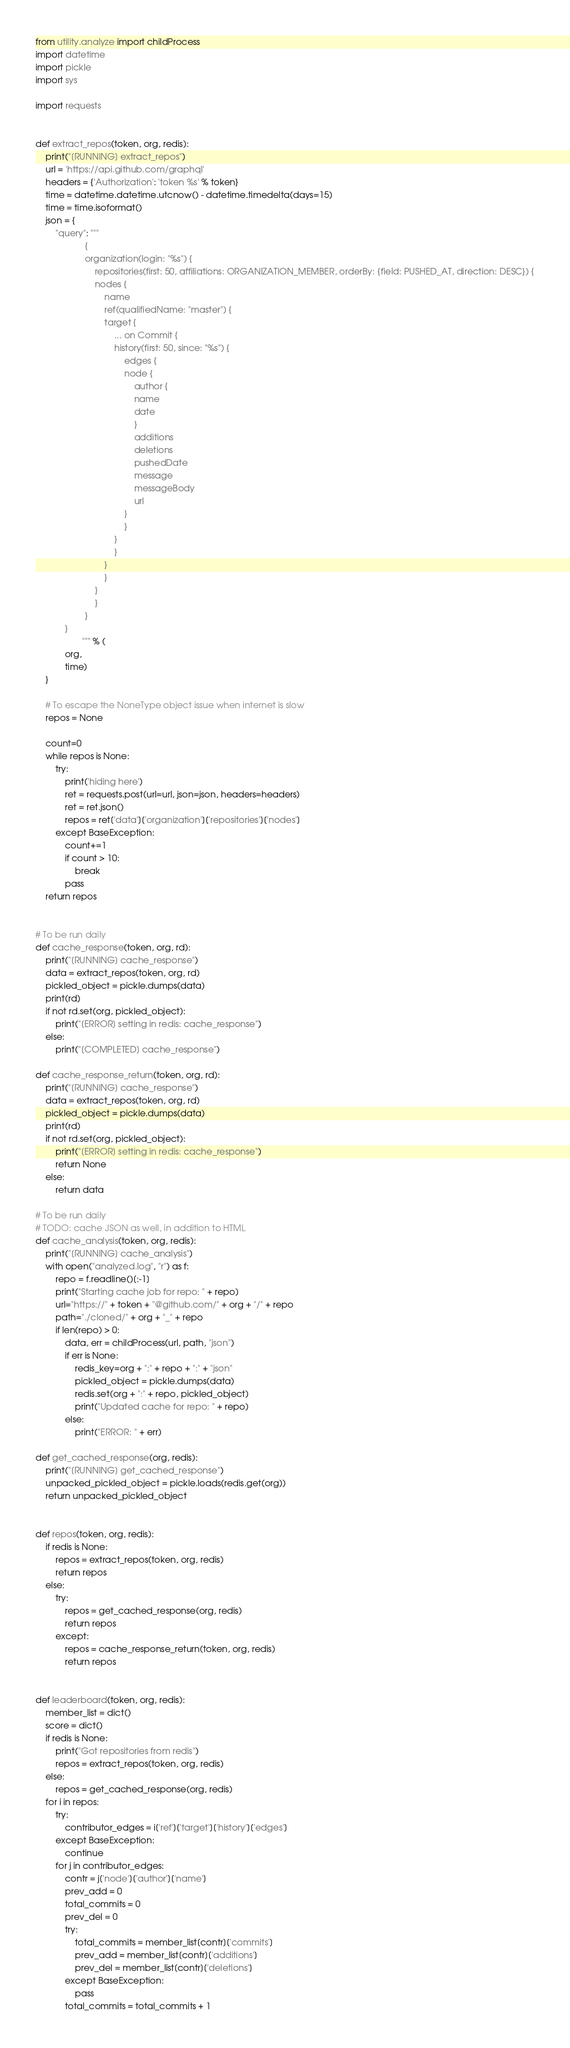<code> <loc_0><loc_0><loc_500><loc_500><_Python_>from utility.analyze import childProcess
import datetime
import pickle
import sys

import requests


def extract_repos(token, org, redis):
    print("[RUNNING] extract_repos")
    url = 'https://api.github.com/graphql'
    headers = {'Authorization': 'token %s' % token}
    time = datetime.datetime.utcnow() - datetime.timedelta(days=15)
    time = time.isoformat()
    json = {
        "query": """
                    {
                    organization(login: "%s") {
                        repositories(first: 50, affiliations: ORGANIZATION_MEMBER, orderBy: {field: PUSHED_AT, direction: DESC}) {
                        nodes {
                            name
                            ref(qualifiedName: "master") {
                            target {
                                ... on Commit {
                                history(first: 50, since: "%s") {
                                    edges {
                                    node {
                                        author {
                                        name
                                        date
                                        }
                                        additions
                                        deletions
                                        pushedDate
                                        message
                                        messageBody
                                        url
                                    }
                                    }
                                }
                                }
                            }
                            }
                        }
                        }
                    }
            }
                   """ % (
            org,
            time)
    }

    # To escape the NoneType object issue when internet is slow
    repos = None

    count=0
    while repos is None:
        try:
            print('hiding here')
            ret = requests.post(url=url, json=json, headers=headers)
            ret = ret.json()
            repos = ret['data']['organization']['repositories']['nodes']
        except BaseException:
            count+=1
            if count > 10:
                break
            pass
    return repos


# To be run daily
def cache_response(token, org, rd):
    print("[RUNNING] cache_response")
    data = extract_repos(token, org, rd)
    pickled_object = pickle.dumps(data)
    print(rd)
    if not rd.set(org, pickled_object):
        print("[ERROR] setting in redis: cache_response")
    else:
        print("[COMPLETED] cache_response")

def cache_response_return(token, org, rd):
    print("[RUNNING] cache_response")
    data = extract_repos(token, org, rd)
    pickled_object = pickle.dumps(data)
    print(rd)
    if not rd.set(org, pickled_object):
        print("[ERROR] setting in redis: cache_response")
        return None
    else:
        return data

# To be run daily
# TODO: cache JSON as well, in addition to HTML
def cache_analysis(token, org, redis):
    print("[RUNNING] cache_analysis")
    with open("analyzed.log", "r") as f:
        repo = f.readline()[:-1]
        print("Starting cache job for repo: " + repo)
        url="https://" + token + "@github.com/" + org + "/" + repo
        path="./cloned/" + org + "_" + repo
        if len(repo) > 0:
            data, err = childProcess(url, path, "json")
            if err is None:
                redis_key=org + ":" + repo + ":" + "json"
                pickled_object = pickle.dumps(data)
                redis.set(org + ":" + repo, pickled_object)
                print("Updated cache for repo: " + repo)
            else:
                print("ERROR: " + err)

def get_cached_response(org, redis):
    print("[RUNNING] get_cached_response")
    unpacked_pickled_object = pickle.loads(redis.get(org))
    return unpacked_pickled_object


def repos(token, org, redis):
    if redis is None:
        repos = extract_repos(token, org, redis)
        return repos
    else:
        try:
            repos = get_cached_response(org, redis)
            return repos
        except:
            repos = cache_response_return(token, org, redis)
            return repos


def leaderboard(token, org, redis):
    member_list = dict()
    score = dict()
    if redis is None:
        print("Got repositories from redis")
        repos = extract_repos(token, org, redis)
    else:
        repos = get_cached_response(org, redis)
    for i in repos:
        try:
            contributor_edges = i['ref']['target']['history']['edges']
        except BaseException:
            continue
        for j in contributor_edges:
            contr = j['node']['author']['name']
            prev_add = 0
            total_commits = 0
            prev_del = 0
            try:
                total_commits = member_list[contr]['commits']
                prev_add = member_list[contr]['additions']
                prev_del = member_list[contr]['deletions']
            except BaseException:
                pass
            total_commits = total_commits + 1</code> 